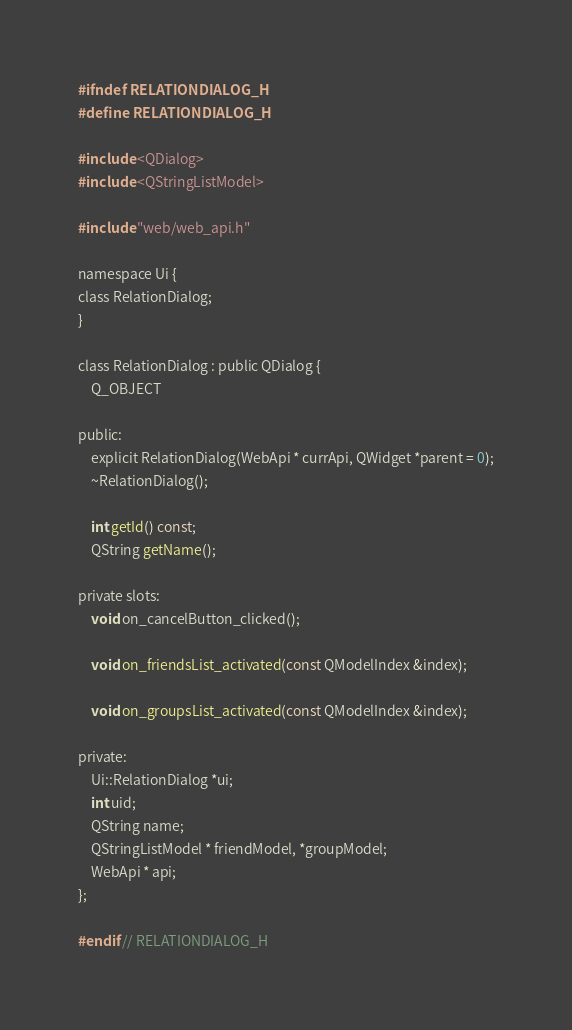<code> <loc_0><loc_0><loc_500><loc_500><_C_>#ifndef RELATIONDIALOG_H
#define RELATIONDIALOG_H

#include <QDialog>
#include <QStringListModel>

#include "web/web_api.h"

namespace Ui {
class RelationDialog;
}

class RelationDialog : public QDialog {
    Q_OBJECT

public:
    explicit RelationDialog(WebApi * currApi, QWidget *parent = 0);
    ~RelationDialog();

    int getId() const;
    QString getName();

private slots:
    void on_cancelButton_clicked();

    void on_friendsList_activated(const QModelIndex &index);

    void on_groupsList_activated(const QModelIndex &index);

private:
    Ui::RelationDialog *ui;
    int uid;
    QString name;
    QStringListModel * friendModel, *groupModel;
    WebApi * api;
};

#endif // RELATIONDIALOG_H
</code> 